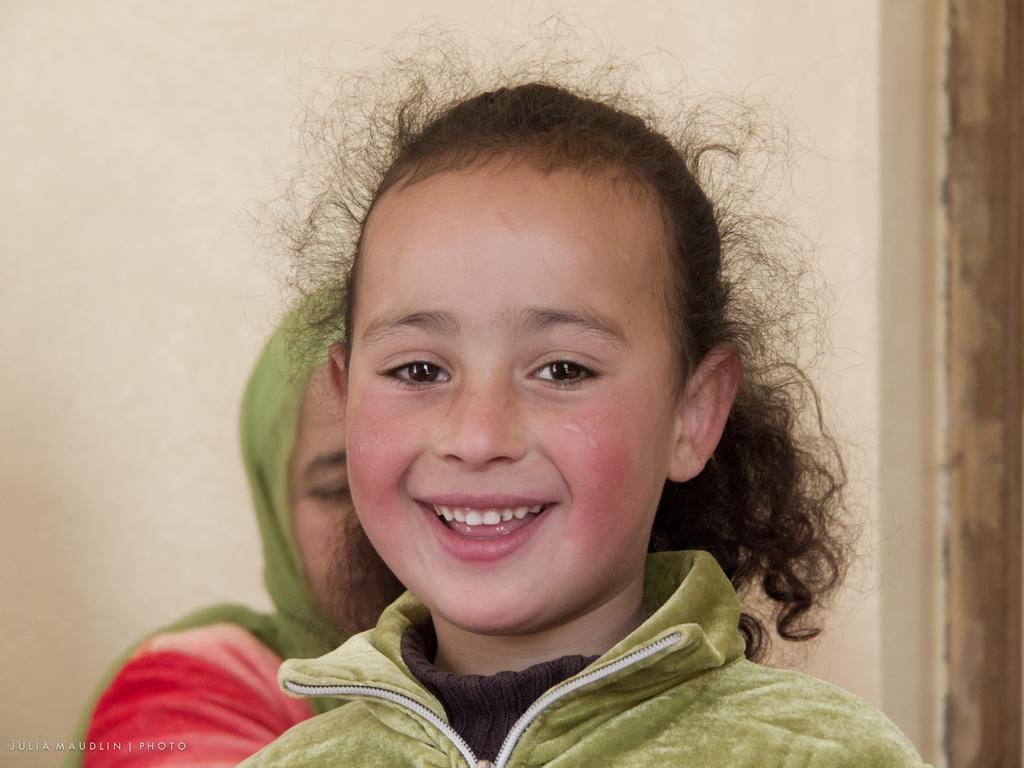Describe this image in one or two sentences. In this image a girl is smiling and she is wearing green color hoodie and brown color T-shirt, behind her there is woman and in the background there is wall. 